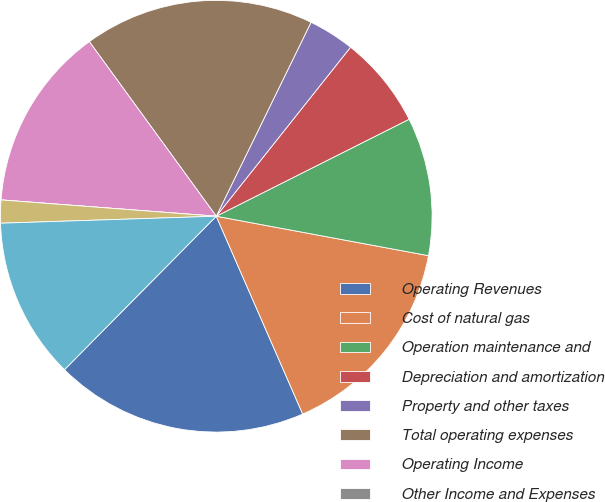Convert chart. <chart><loc_0><loc_0><loc_500><loc_500><pie_chart><fcel>Operating Revenues<fcel>Cost of natural gas<fcel>Operation maintenance and<fcel>Depreciation and amortization<fcel>Property and other taxes<fcel>Total operating expenses<fcel>Operating Income<fcel>Other Income and Expenses<fcel>Interest Expense<fcel>Income Before Income Taxes<nl><fcel>18.97%<fcel>15.52%<fcel>10.34%<fcel>6.9%<fcel>3.45%<fcel>17.24%<fcel>13.79%<fcel>0.0%<fcel>1.72%<fcel>12.07%<nl></chart> 